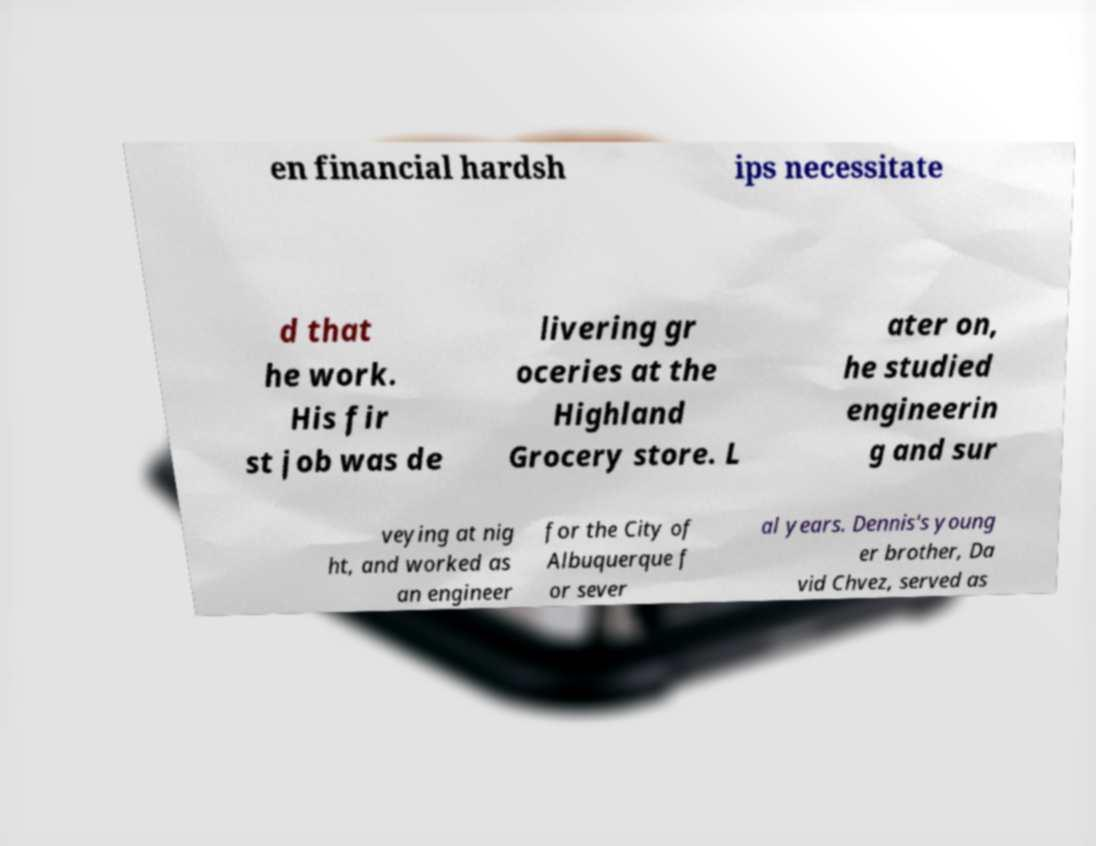Can you read and provide the text displayed in the image?This photo seems to have some interesting text. Can you extract and type it out for me? en financial hardsh ips necessitate d that he work. His fir st job was de livering gr oceries at the Highland Grocery store. L ater on, he studied engineerin g and sur veying at nig ht, and worked as an engineer for the City of Albuquerque f or sever al years. Dennis's young er brother, Da vid Chvez, served as 